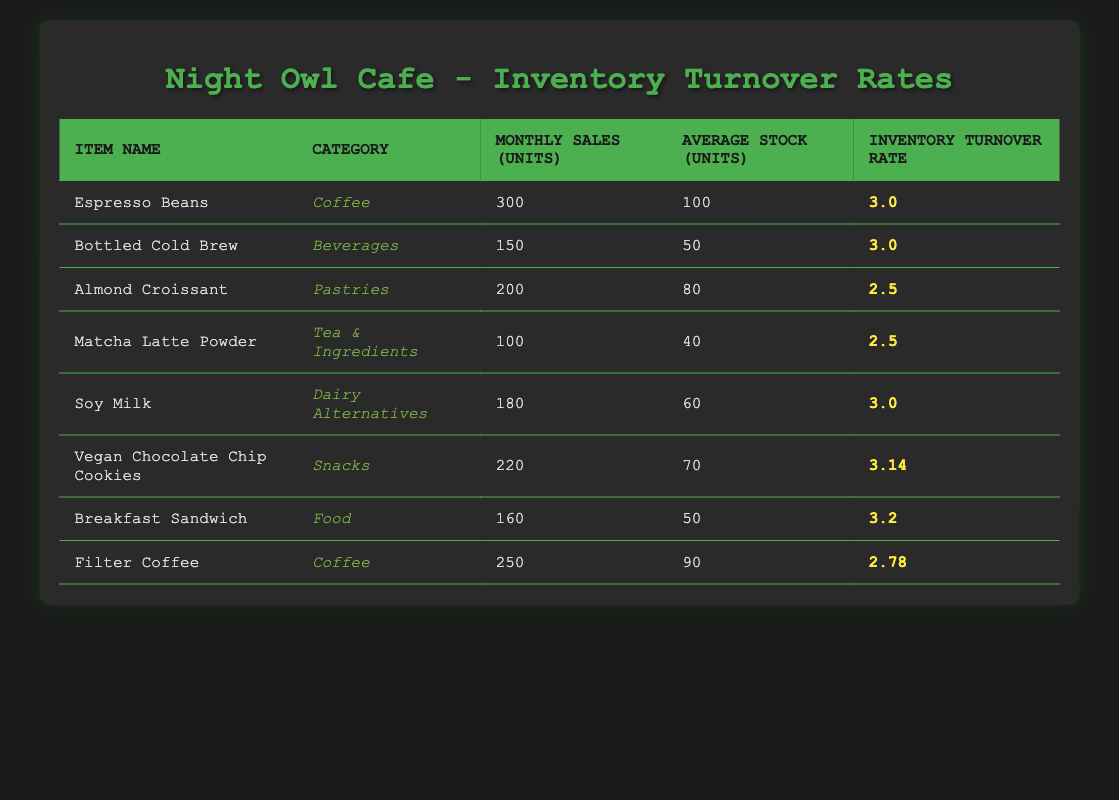What is the inventory turnover rate for Espresso Beans? The inventory turnover rate is listed directly in the table under the corresponding item. For Espresso Beans, it is indicated as 3.0.
Answer: 3.0 Which item has the highest inventory turnover rate? By comparing the inventory turnover rates from the table, Vegan Chocolate Chip Cookies has the highest rate at 3.14.
Answer: Vegan Chocolate Chip Cookies What is the average monthly sales of all items combined? To find the average, first sum the monthly sales: 300 + 150 + 200 + 100 + 180 + 220 + 160 + 250 = 1560. Then divide by the number of items, which is 8: so, 1560/8 = 195.
Answer: 195 Is the inventory turnover rate for Almond Croissant greater than 3? The inventory turnover rate for Almond Croissant is recorded as 2.5 in the table, which is less than 3. Thus, the statement is false.
Answer: No What is the total average stock of all food items? The food items in the table are Breakfast Sandwich (50 average stock) and Almond Croissant (80 average stock). Therefore, the total average stock is 50 + 80 = 130.
Answer: 130 What percentage of items have an inventory turnover rate above 3? There are a total of 8 items in the table. The items with rates above 3 are Espresso Beans, Bottled Cold Brew, Soy Milk, Vegan Chocolate Chip Cookies, and Breakfast Sandwich, which totals 5 items. The percentage is (5/8) * 100 = 62.5%.
Answer: 62.5% How many items belong to the Coffee category? Filtering the table by category shows two items labeled as Coffee: Espresso Beans and Filter Coffee. Therefore, the count is 2.
Answer: 2 Which item has the lowest monthly sales, and what are its sales figures? By examining the monthly sales units in the table, Matcha Latte Powder has the lowest with 100 sales units.
Answer: Matcha Latte Powder, 100 